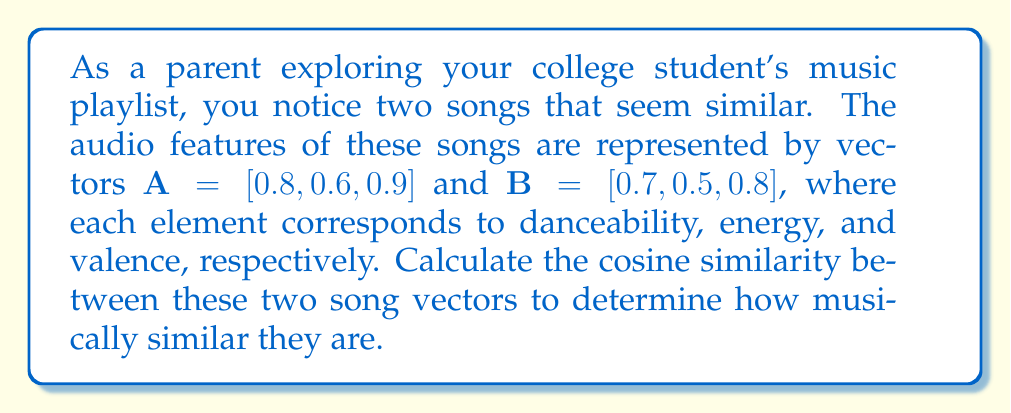Teach me how to tackle this problem. To compute the cosine similarity between two vectors, we use the formula:

$$\text{cosine similarity} = \frac{\mathbf{A} \cdot \mathbf{B}}{\|\mathbf{A}\| \|\mathbf{B}\|}$$

Where $\mathbf{A} \cdot \mathbf{B}$ is the dot product of the vectors, and $\|\mathbf{A}\|$ and $\|\mathbf{B}\|$ are the magnitudes (Euclidean norms) of vectors A and B respectively.

Step 1: Calculate the dot product $\mathbf{A} \cdot \mathbf{B}$
$\mathbf{A} \cdot \mathbf{B} = (0.8 \times 0.7) + (0.6 \times 0.5) + (0.9 \times 0.8) = 0.56 + 0.30 + 0.72 = 1.58$

Step 2: Calculate $\|\mathbf{A}\|$
$\|\mathbf{A}\| = \sqrt{0.8^2 + 0.6^2 + 0.9^2} = \sqrt{0.64 + 0.36 + 0.81} = \sqrt{1.81} \approx 1.3454$

Step 3: Calculate $\|\mathbf{B}\|$
$\|\mathbf{B}\| = \sqrt{0.7^2 + 0.5^2 + 0.8^2} = \sqrt{0.49 + 0.25 + 0.64} = \sqrt{1.38} \approx 1.1747$

Step 4: Apply the cosine similarity formula
$$\text{cosine similarity} = \frac{1.58}{1.3454 \times 1.1747} \approx 0.9986$$
Answer: The cosine similarity between the two song vectors is approximately 0.9986. 